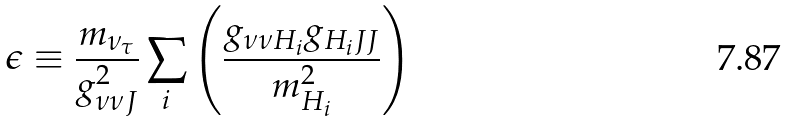<formula> <loc_0><loc_0><loc_500><loc_500>\epsilon \equiv \frac { m _ { \nu _ { \tau } } } { g ^ { 2 } _ { \nu \nu J } } \sum _ { i } \left ( \frac { g _ { \nu \nu H _ { i } } g _ { H _ { i } J J } } { m ^ { 2 } _ { H _ { i } } } \right )</formula> 